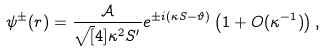<formula> <loc_0><loc_0><loc_500><loc_500>\psi ^ { \pm } ( r ) = \frac { \mathcal { A } } { \sqrt { [ } 4 ] { \kappa ^ { 2 } S ^ { \prime } } } e ^ { \pm i \left ( \kappa S - \vartheta \right ) } \left ( 1 + O ( \kappa ^ { - 1 } ) \right ) ,</formula> 